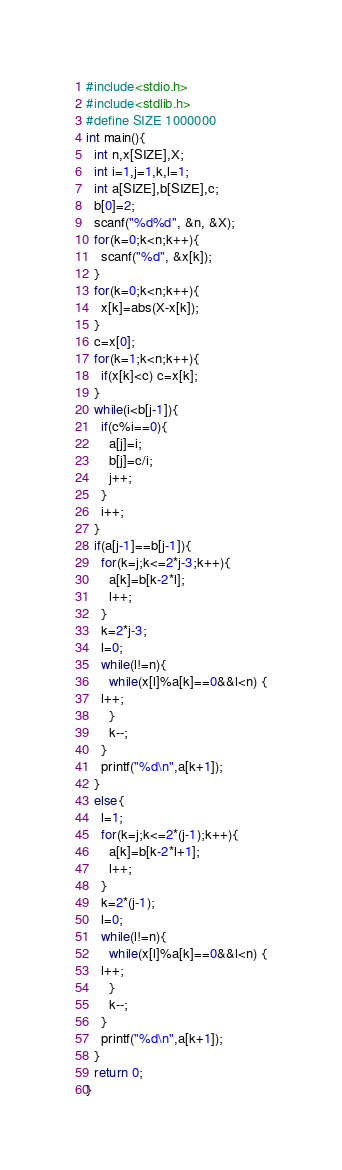Convert code to text. <code><loc_0><loc_0><loc_500><loc_500><_C_>#include<stdio.h>
#include<stdlib.h>
#define SIZE 1000000
int main(){
  int n,x[SIZE],X;
  int i=1,j=1,k,l=1;
  int a[SIZE],b[SIZE],c;
  b[0]=2;
  scanf("%d%d", &n, &X);
  for(k=0;k<n;k++){
    scanf("%d", &x[k]);
  }
  for(k=0;k<n;k++){
    x[k]=abs(X-x[k]);
  }
  c=x[0];
  for(k=1;k<n;k++){
    if(x[k]<c) c=x[k];
  }
  while(i<b[j-1]){
    if(c%i==0){
      a[j]=i;
      b[j]=c/i;
      j++;
    }
    i++;
  }
  if(a[j-1]==b[j-1]){
    for(k=j;k<=2*j-3;k++){
      a[k]=b[k-2*l];
      l++;
    }
    k=2*j-3;
    l=0;
    while(l!=n){
      while(x[l]%a[k]==0&&l<n) {
	l++;
      }
      k--;
    }
    printf("%d\n",a[k+1]);
  }
  else{
    l=1;
    for(k=j;k<=2*(j-1);k++){
      a[k]=b[k-2*l+1];
      l++;
    }
    k=2*(j-1);
    l=0;
    while(l!=n){
      while(x[l]%a[k]==0&&l<n) {
	l++;
      }
      k--;
    }
    printf("%d\n",a[k+1]);
  }    
  return 0;
}
</code> 